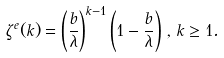Convert formula to latex. <formula><loc_0><loc_0><loc_500><loc_500>\zeta ^ { e } ( k ) = \left ( \frac { b } { \lambda } \right ) ^ { k - 1 } \left ( 1 - \frac { b } { \lambda } \right ) \, , \, k \geq 1 .</formula> 